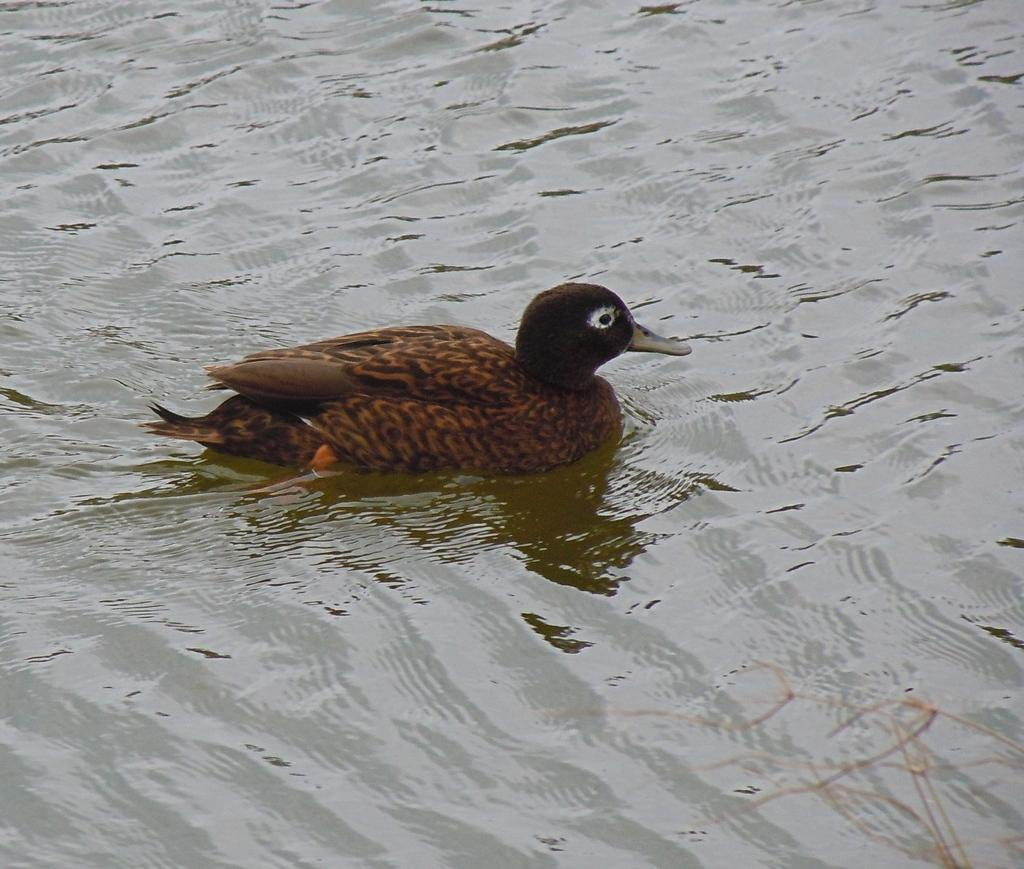What type of animal is present in the image? There is a duck in the image. Where is the duck located? The duck is in a water body. What hobbies does the duck have in the image? There is no information about the duck's hobbies in the image. What instrument is the duck playing in the image? There is no instrument present in the image, and the duck is not playing any instrument. 